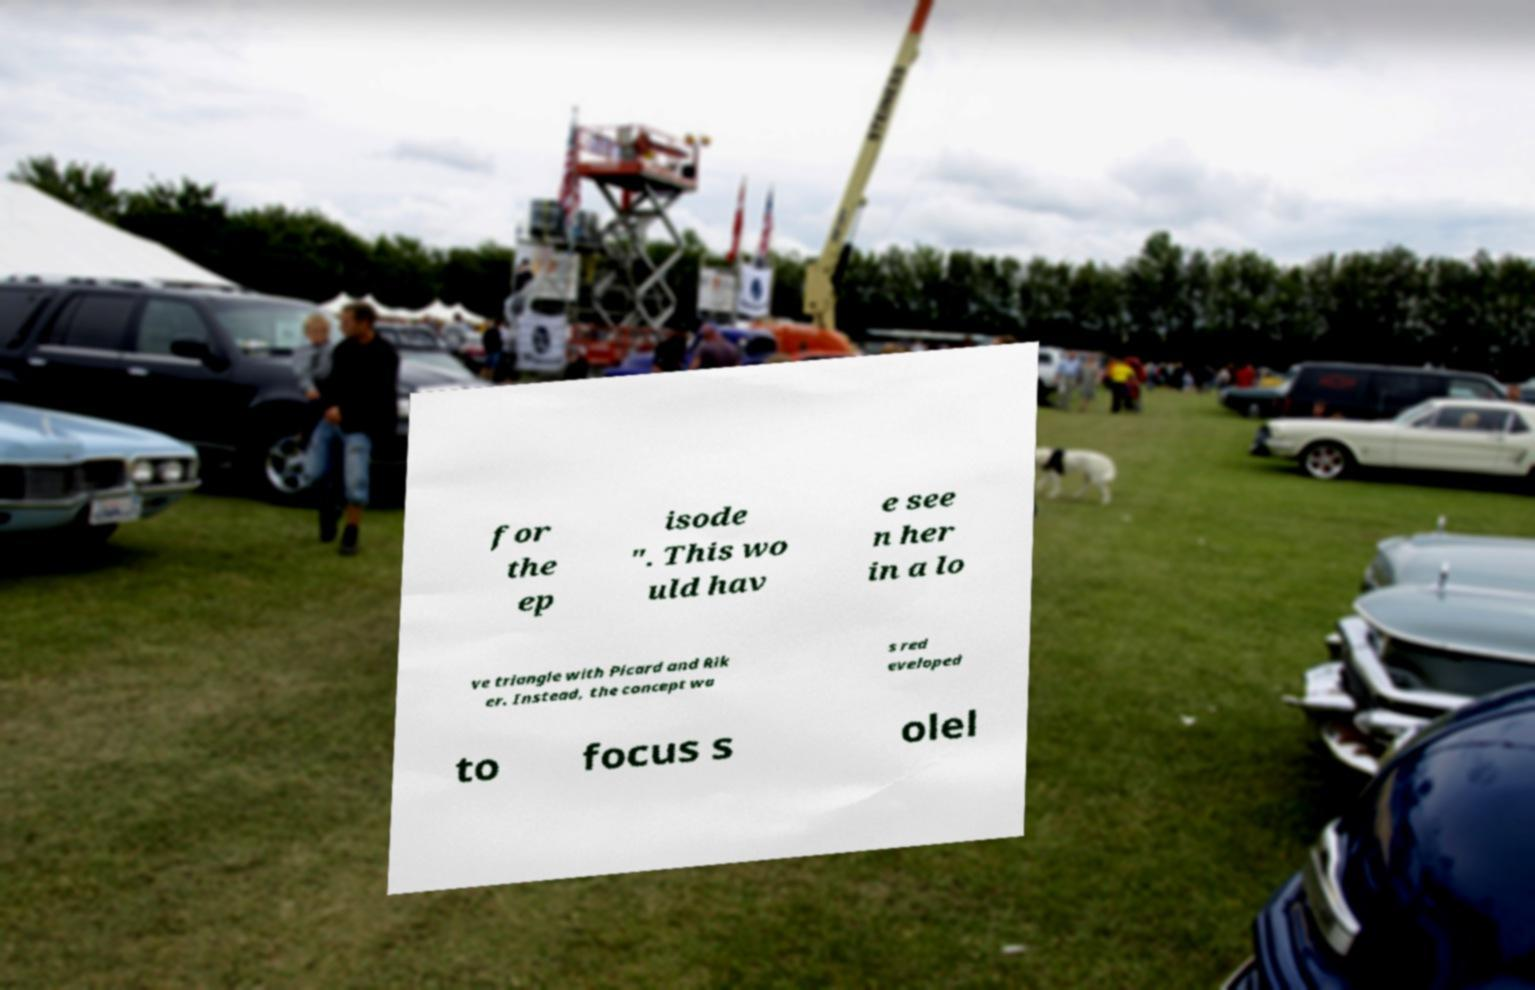Can you read and provide the text displayed in the image?This photo seems to have some interesting text. Can you extract and type it out for me? for the ep isode ". This wo uld hav e see n her in a lo ve triangle with Picard and Rik er. Instead, the concept wa s red eveloped to focus s olel 